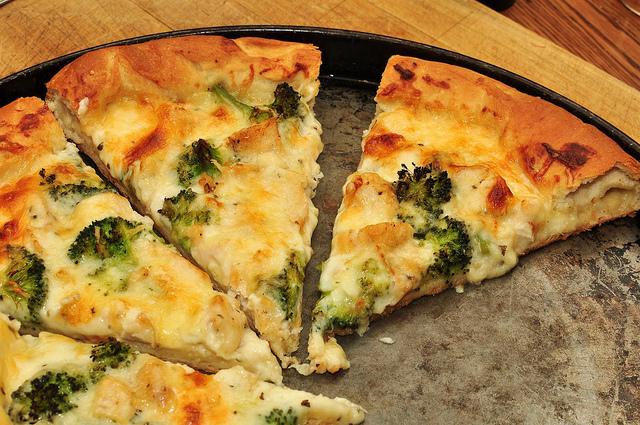Is any of the pizza missing?
Be succinct. Yes. What vegetable is on the pizza?
Quick response, please. Broccoli. Is this safe for a lactose intolerant person?
Concise answer only. No. 